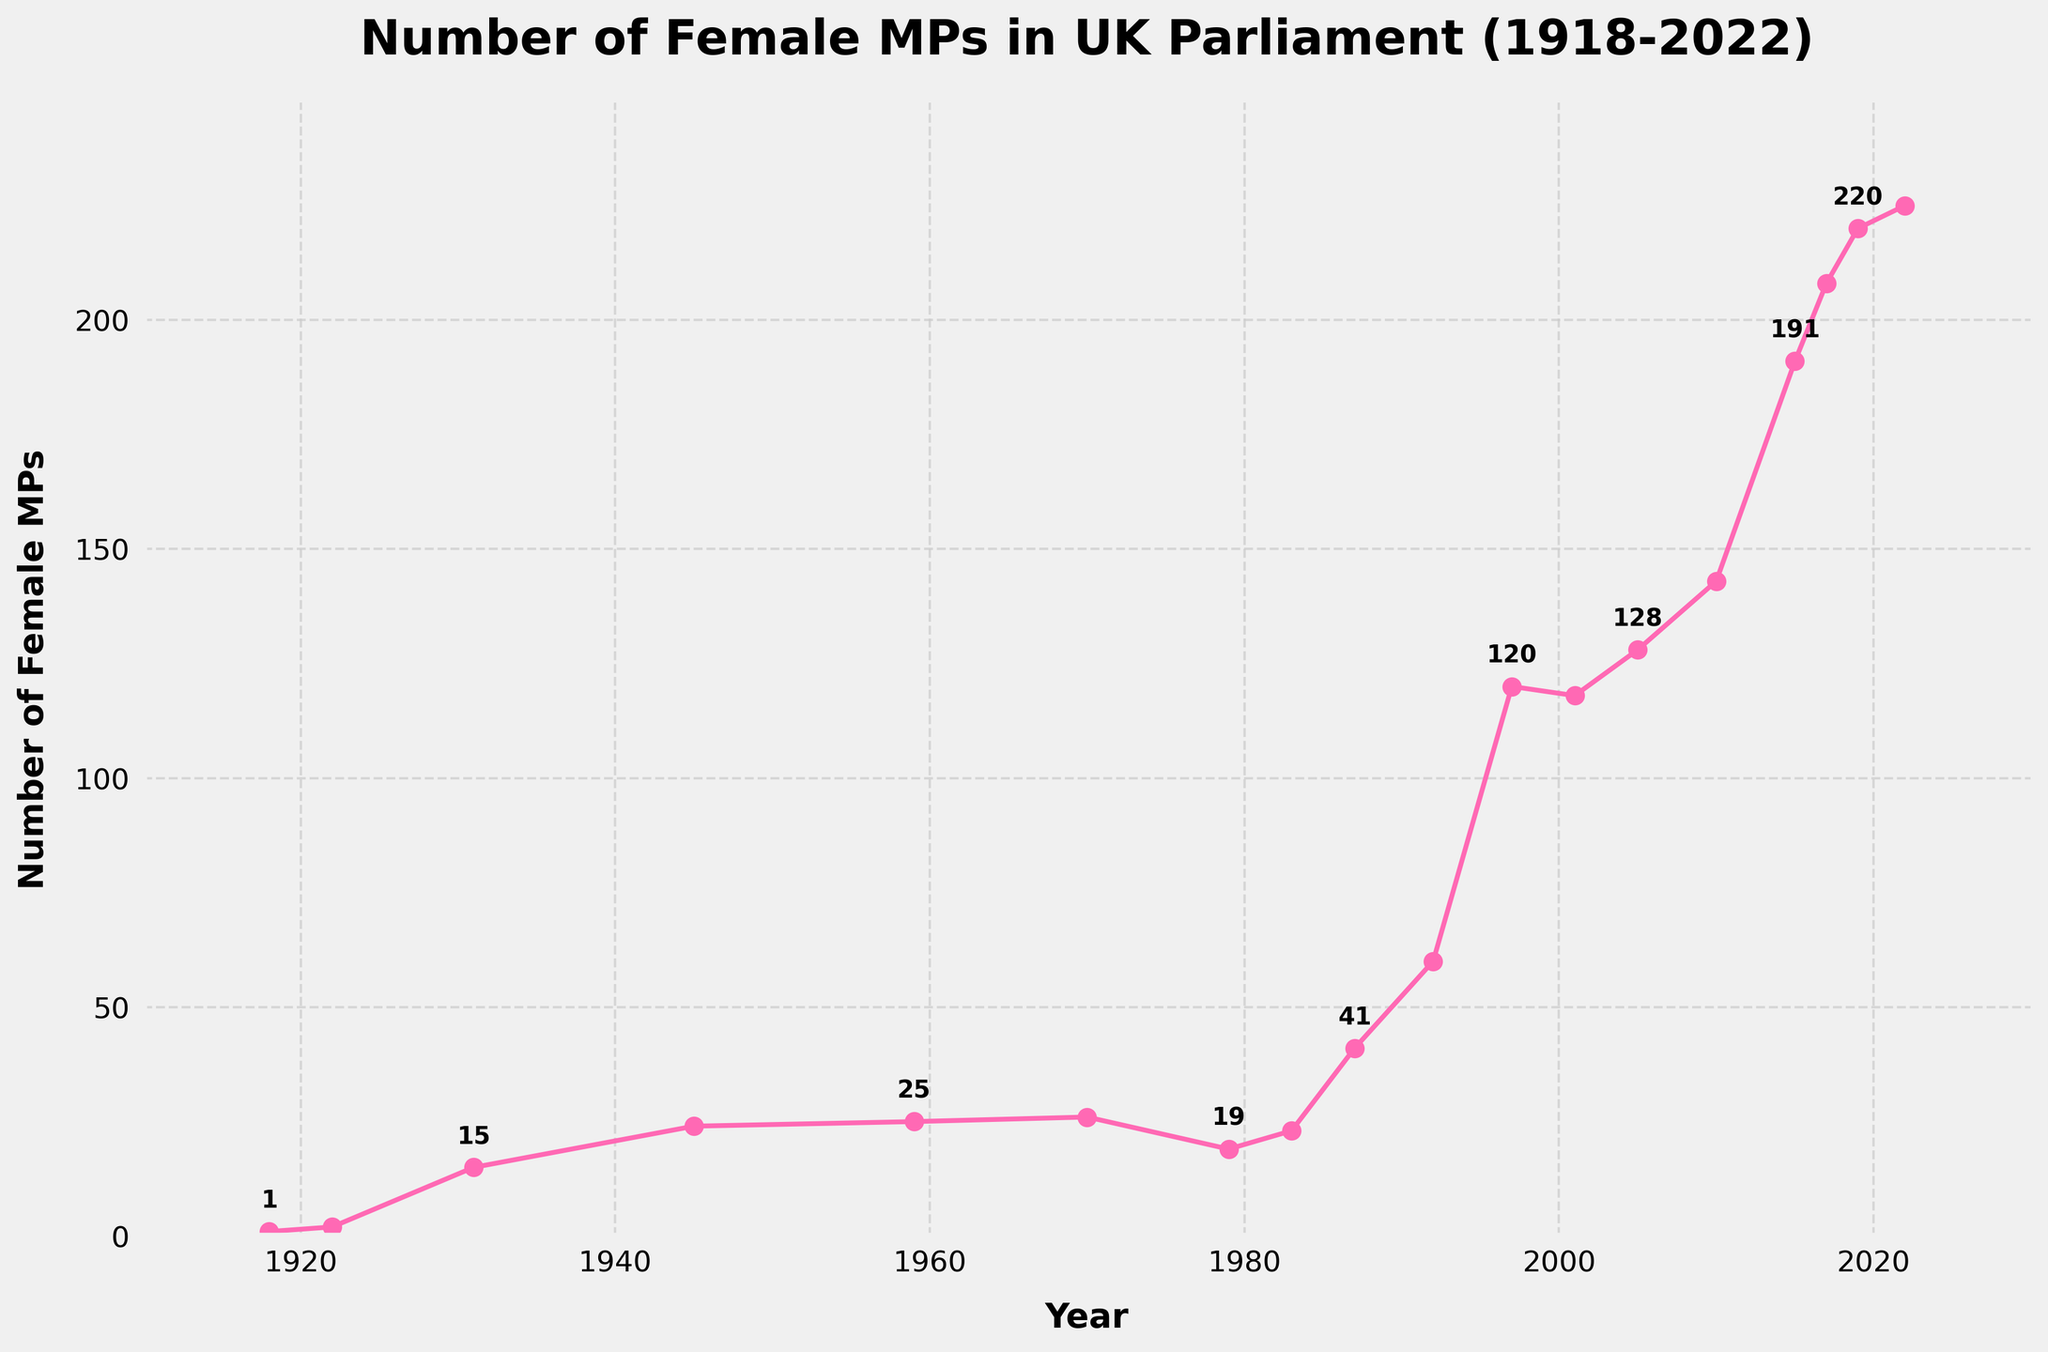Which year had the highest number of female MPs? By examining the line chart, the peak of the graph indicates the year with the highest number of female MPs. This peak is observed in 2022.
Answer: 2022 Between 1931 and 1970, did the number of female MPs ever decrease? To answer this, check the trend on the chart from 1931 to 1970. It shows either increases or remains constant at most points; thus, there were no overall decreases.
Answer: No What is the increase in the number of female MPs from 1992 to 1997? Find the values for 1992 and 1997. The number of female MPs increased from 60 in 1992 to 120 in 1997. The difference is 120 - 60 = 60.
Answer: 60 What is the average number of female MPs from 1918 to 2019? Sum the values of female MPs from the years 1918 to 2019 and divide by the number of years. (1 + 2 + 15 + 24 + 25 + 26 + 19 + 23 + 41 + 60 + 120 + 118 + 128 + 143 + 191 + 208 + 220) / 17 = 1021 / 17 ≈ 60.06.
Answer: 60.06 Which decade saw the most significant increase in the number of female MPs? Review the trend line by decade and compare the difference between starting and ending values. The 1990s saw an increase from 60 in 1992 to 120 in 1997, a total change of 60 MPs, which is the highest observed.
Answer: 1990s Compare the number of female MPs in 1979 and 1997; which year had more? Locate the points for the years 1979 and 1997 on the chart. 1979 had 19 female MPs while 1997 had 120 female MPs.
Answer: 1997 From 1987 to 2001, what is the total increase in the number of female MPs? Find the values for 1987 and 2001. The number of MPs increased from 41 in 1987 to 118 in 2001. The difference is 118 - 41 = 77.
Answer: 77 What is the overall trend in the number of female MPs from 1918 to 2022? By observing the entire chart, one can see a general upward trend with minor fluctuations, indicating a steady increase over the years.
Answer: Increasing Between which two consecutive years did the number of female MPs decrease? Examine the chart for any downward trends between consecutive years. The number decreased from 26 in 1970 to 19 in 1979.
Answer: 1970 and 1979 How many times did the number of female MPs stay the same between consecutive recordings? Check the chart for flat segments between consecutive points. The number stayed the same once, between 2001 and 2005 with 118 female MPs each.
Answer: Once 